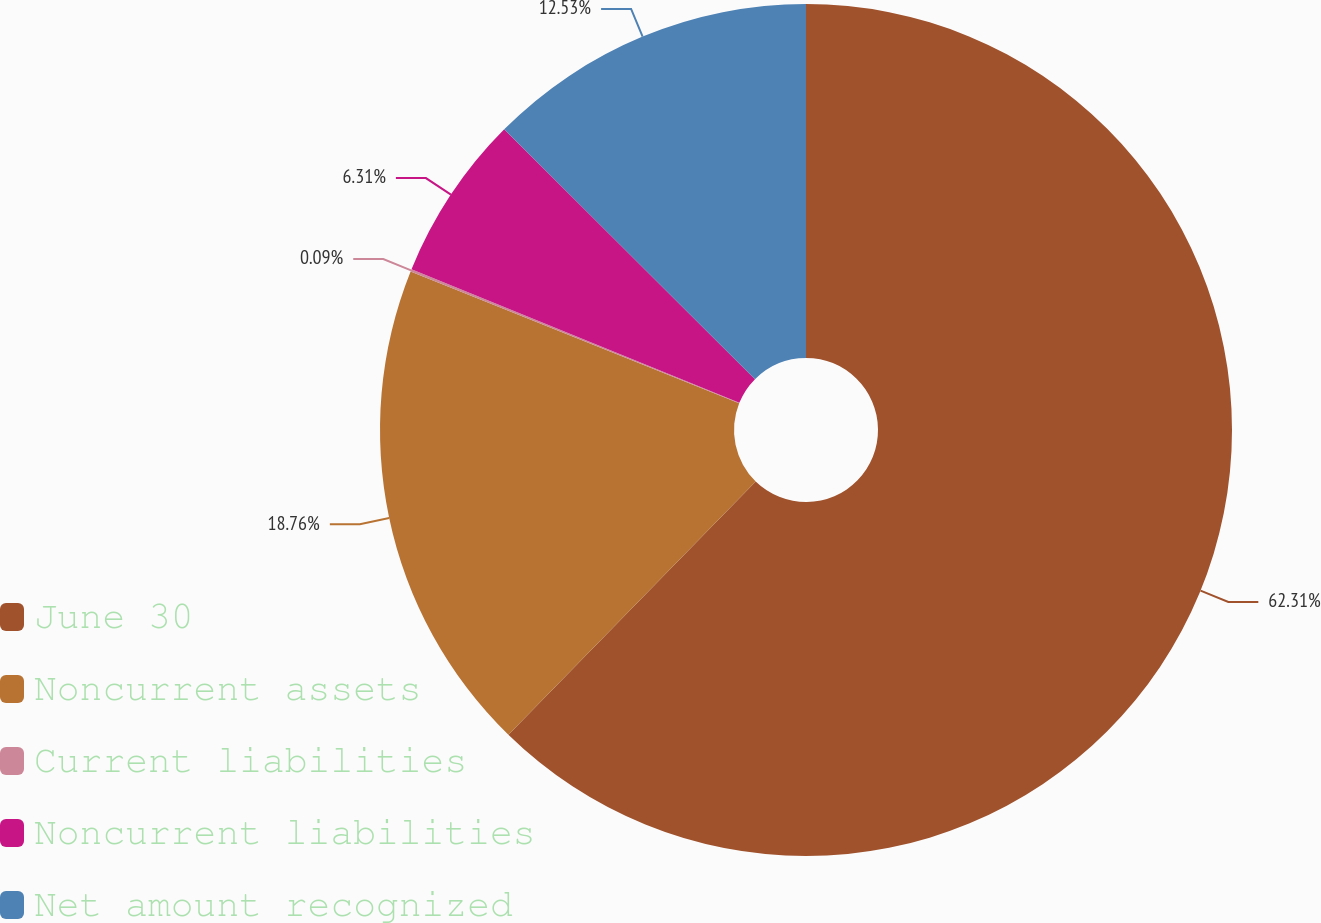Convert chart. <chart><loc_0><loc_0><loc_500><loc_500><pie_chart><fcel>June 30<fcel>Noncurrent assets<fcel>Current liabilities<fcel>Noncurrent liabilities<fcel>Net amount recognized<nl><fcel>62.31%<fcel>18.76%<fcel>0.09%<fcel>6.31%<fcel>12.53%<nl></chart> 